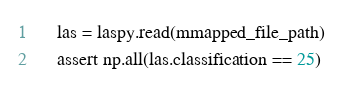Convert code to text. <code><loc_0><loc_0><loc_500><loc_500><_Python_>
    las = laspy.read(mmapped_file_path)
    assert np.all(las.classification == 25)
</code> 